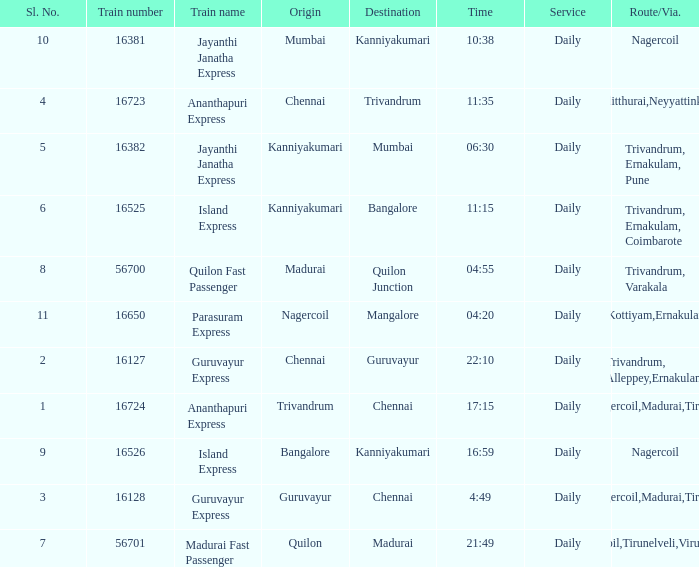What is the train number when the time is 10:38? 16381.0. 